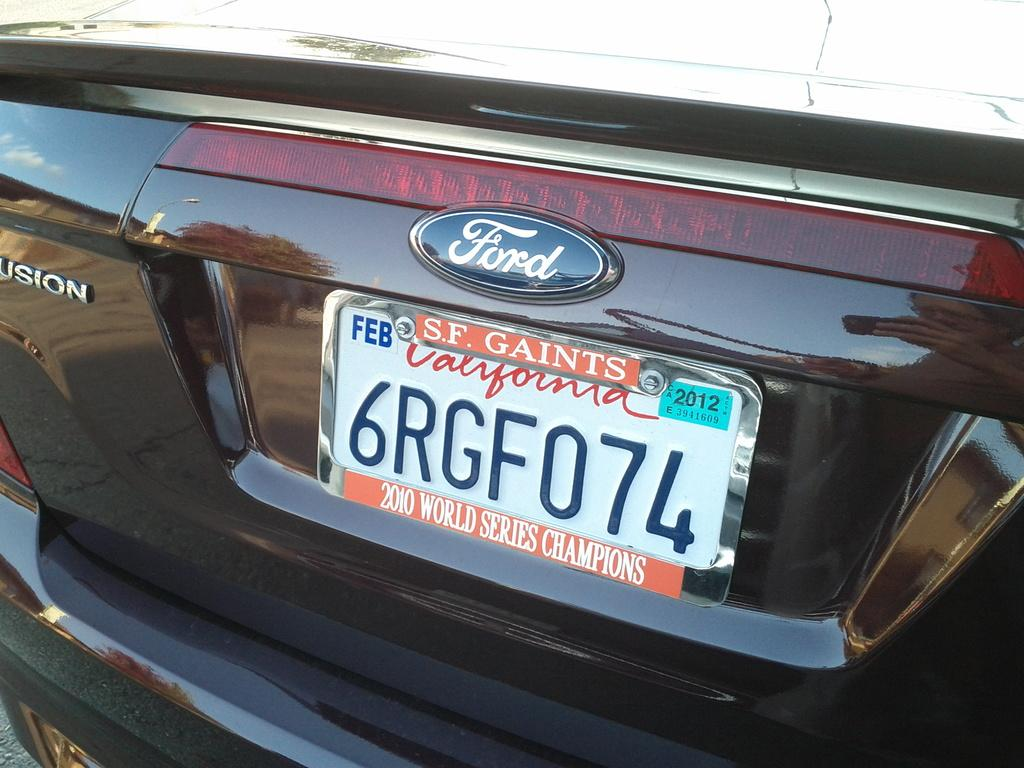<image>
Summarize the visual content of the image. A dark red ford vehicle with tag number 6RGF074. 